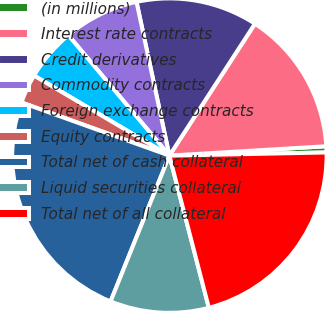<chart> <loc_0><loc_0><loc_500><loc_500><pie_chart><fcel>(in millions)<fcel>Interest rate contracts<fcel>Credit derivatives<fcel>Commodity contracts<fcel>Foreign exchange contracts<fcel>Equity contracts<fcel>Total net of cash collateral<fcel>Liquid securities collateral<fcel>Total net of all collateral<nl><fcel>0.63%<fcel>14.89%<fcel>12.51%<fcel>7.76%<fcel>5.39%<fcel>3.01%<fcel>24.39%<fcel>10.14%<fcel>21.28%<nl></chart> 